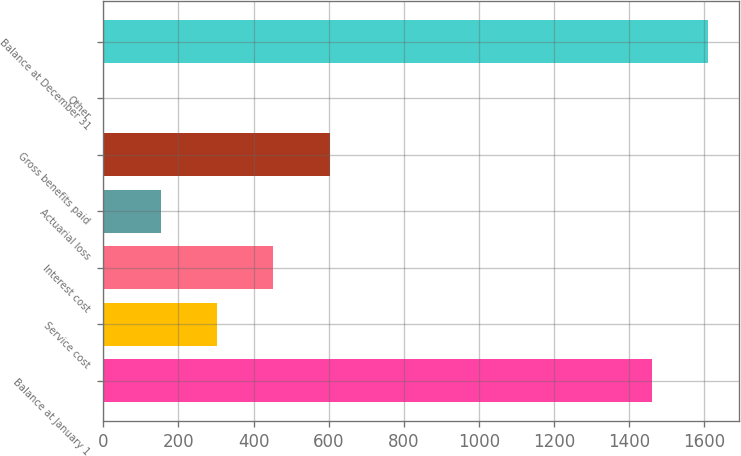<chart> <loc_0><loc_0><loc_500><loc_500><bar_chart><fcel>Balance at January 1<fcel>Service cost<fcel>Interest cost<fcel>Actuarial loss<fcel>Gross benefits paid<fcel>Other<fcel>Balance at December 31<nl><fcel>1460<fcel>302.6<fcel>452.9<fcel>152.3<fcel>603.2<fcel>2<fcel>1610.3<nl></chart> 